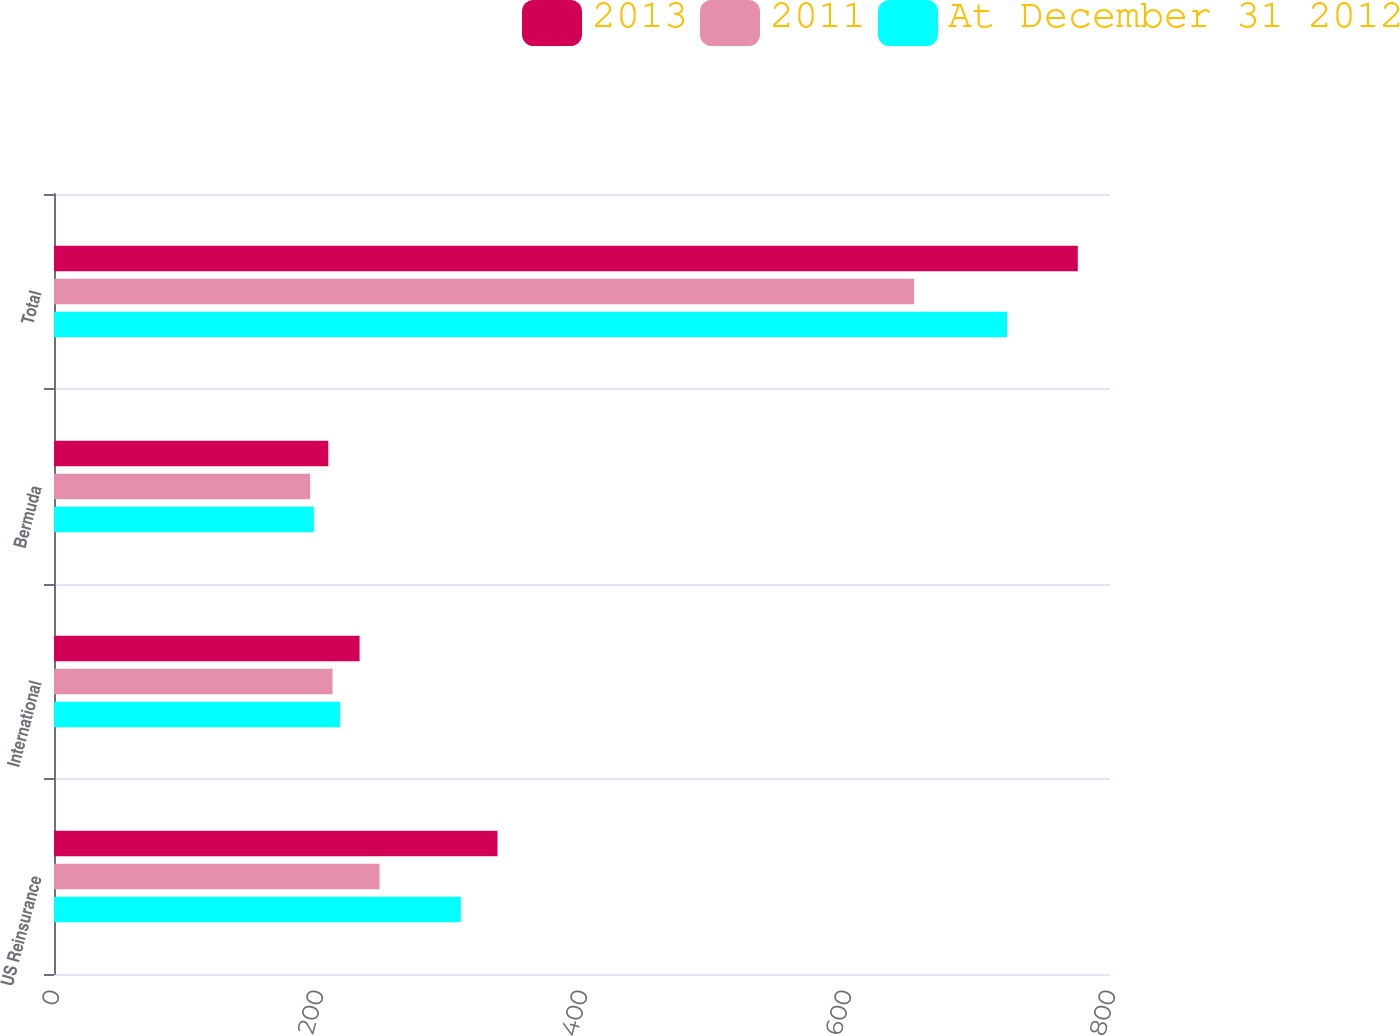<chart> <loc_0><loc_0><loc_500><loc_500><stacked_bar_chart><ecel><fcel>US Reinsurance<fcel>International<fcel>Bermuda<fcel>Total<nl><fcel>2013<fcel>336<fcel>231.5<fcel>207.8<fcel>775.6<nl><fcel>2011<fcel>246.6<fcel>211<fcel>194<fcel>651.6<nl><fcel>At December 31 2012<fcel>308.2<fcel>216.8<fcel>196.9<fcel>722<nl></chart> 